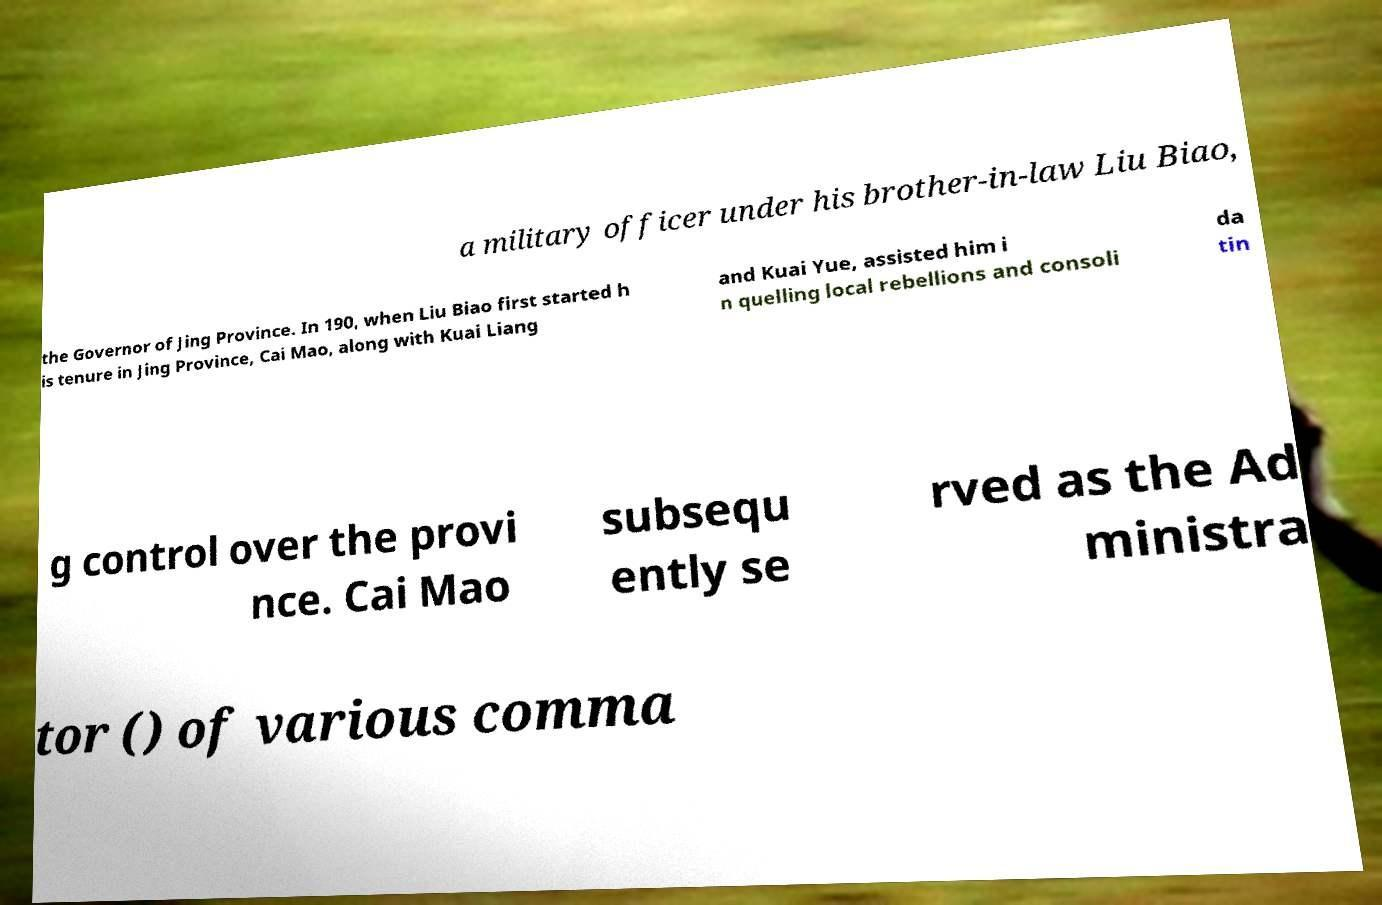I need the written content from this picture converted into text. Can you do that? a military officer under his brother-in-law Liu Biao, the Governor of Jing Province. In 190, when Liu Biao first started h is tenure in Jing Province, Cai Mao, along with Kuai Liang and Kuai Yue, assisted him i n quelling local rebellions and consoli da tin g control over the provi nce. Cai Mao subsequ ently se rved as the Ad ministra tor () of various comma 